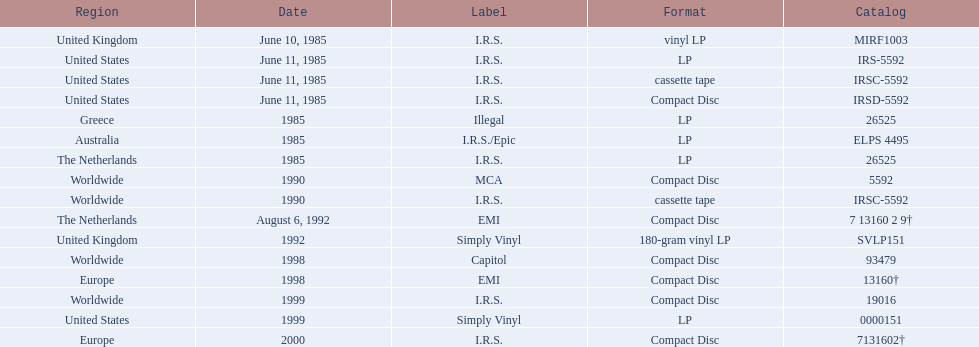Which dates were their releases by fables of the reconstruction? June 10, 1985, June 11, 1985, June 11, 1985, June 11, 1985, 1985, 1985, 1985, 1990, 1990, August 6, 1992, 1992, 1998, 1998, 1999, 1999, 2000. Which of these are in 1985? June 10, 1985, June 11, 1985, June 11, 1985, June 11, 1985, 1985, 1985, 1985. What regions were there releases on these dates? United Kingdom, United States, United States, United States, Greece, Australia, The Netherlands. Which of these are not greece? United Kingdom, United States, United States, United States, Australia, The Netherlands. Which of these regions have two labels listed? Australia. 